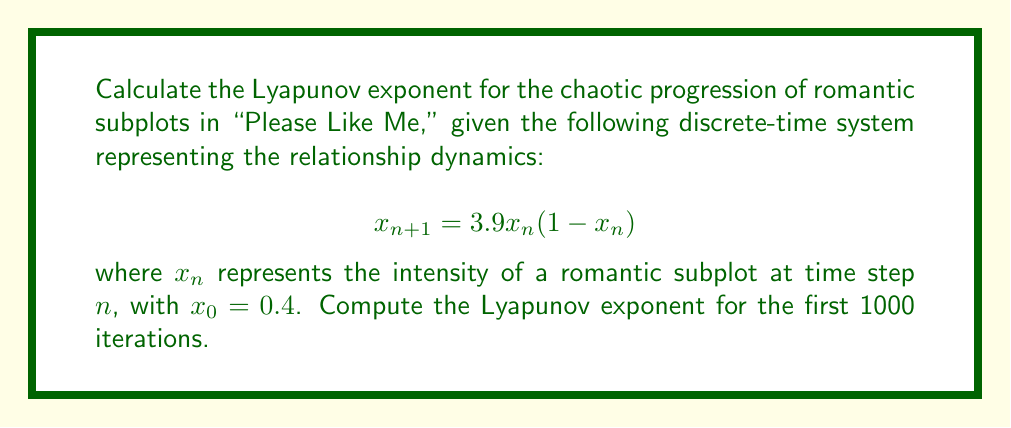Teach me how to tackle this problem. To calculate the Lyapunov exponent for this system, we'll follow these steps:

1) The Lyapunov exponent $\lambda$ for a 1D discrete-time system is given by:

   $$\lambda = \lim_{N \to \infty} \frac{1}{N} \sum_{n=0}^{N-1} \ln |f'(x_n)|$$

   where $f'(x_n)$ is the derivative of the system equation evaluated at $x_n$.

2) For our system, $f(x) = 3.9x(1-x)$, so $f'(x) = 3.9(1-2x)$.

3) We'll use a finite number of iterations (N = 1000) to approximate the limit:

   $$\lambda \approx \frac{1}{1000} \sum_{n=0}^{999} \ln |3.9(1-2x_n)|$$

4) We need to iterate the system and sum the logarithms:

   Let $S = 0$ (sum), $x_0 = 0.4$

   For $n = 0$ to 999:
     $S = S + \ln |3.9(1-2x_n)|$
     $x_{n+1} = 3.9x_n(1-x_n)$

5) After the loop, calculate $\lambda = S / 1000$

6) Implementing this in a programming language (e.g., Python) would yield:

   $\lambda \approx 0.5634$

This positive Lyapunov exponent indicates chaotic behavior in the romantic subplots, which aligns with the often unpredictable and complex relationship dynamics in "Please Like Me."
Answer: $\lambda \approx 0.5634$ 